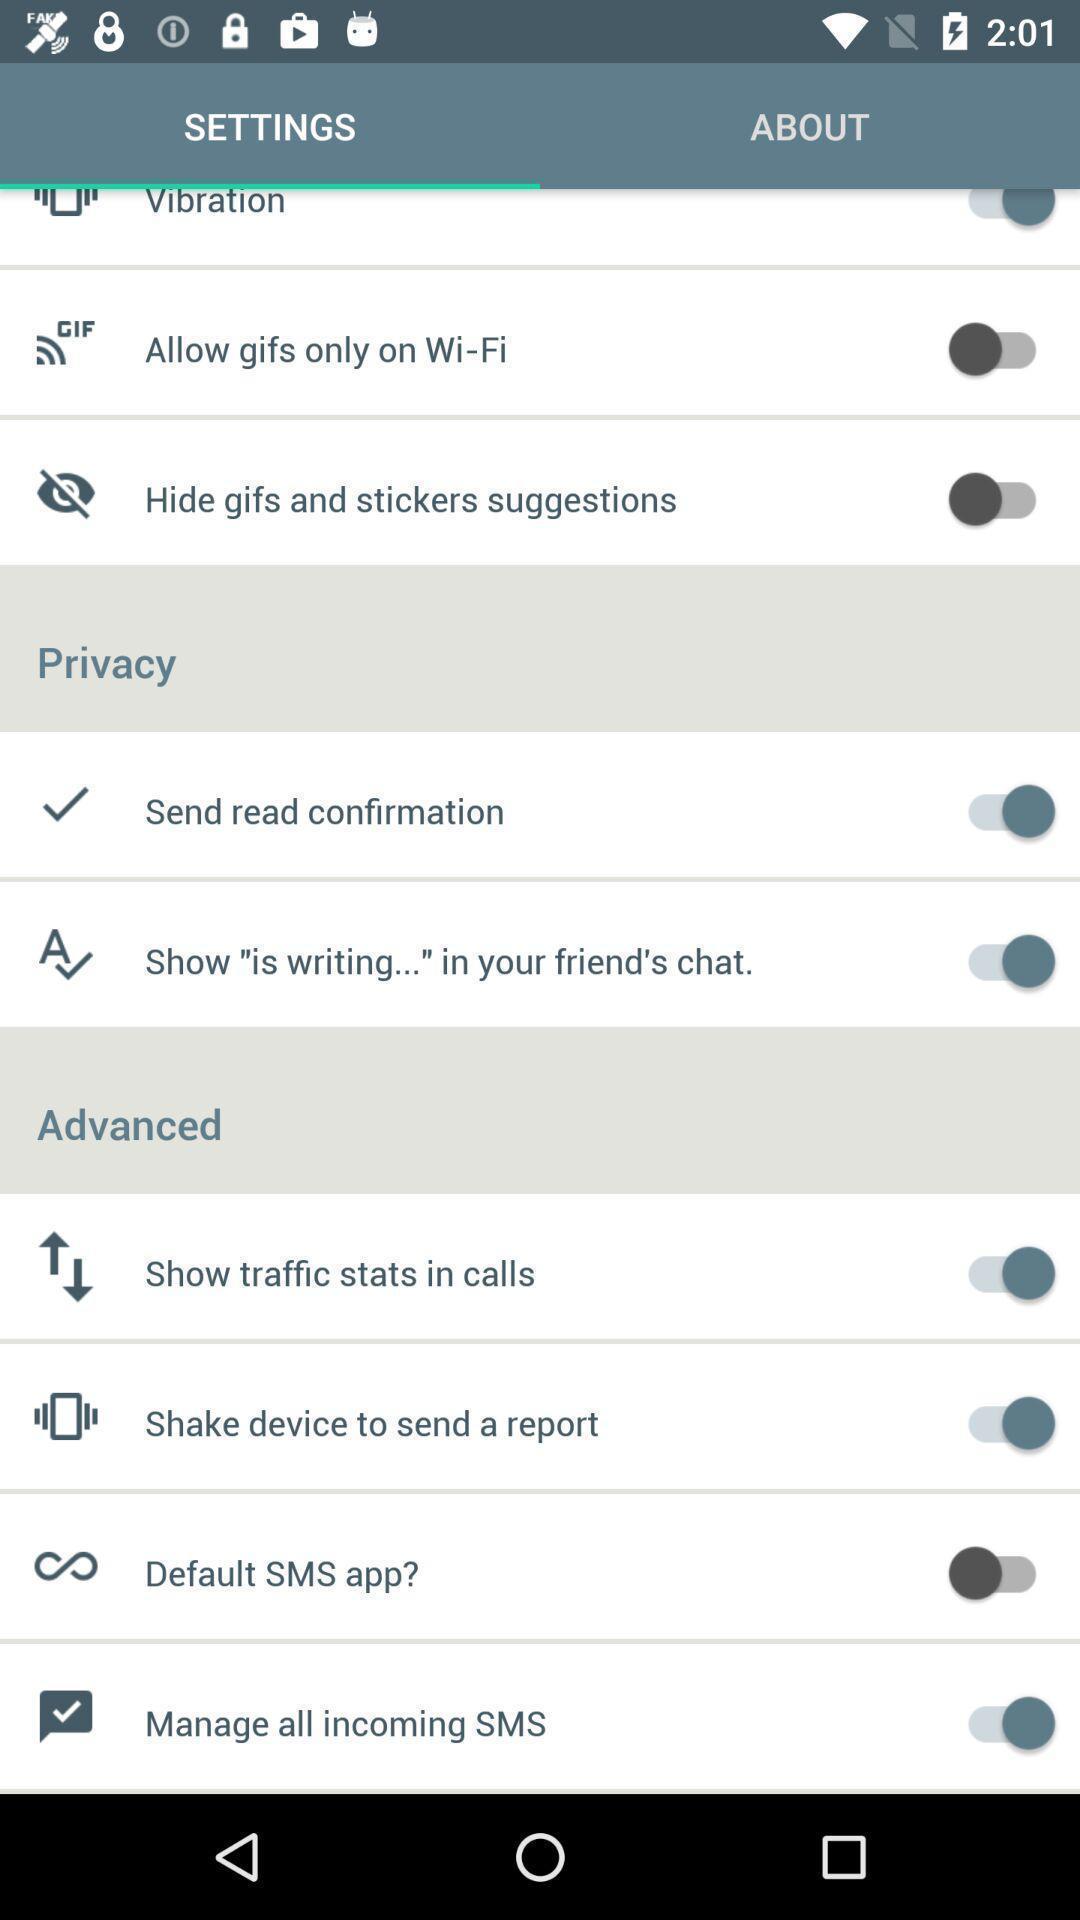What is the overall content of this screenshot? Settings page in a mobile app. 